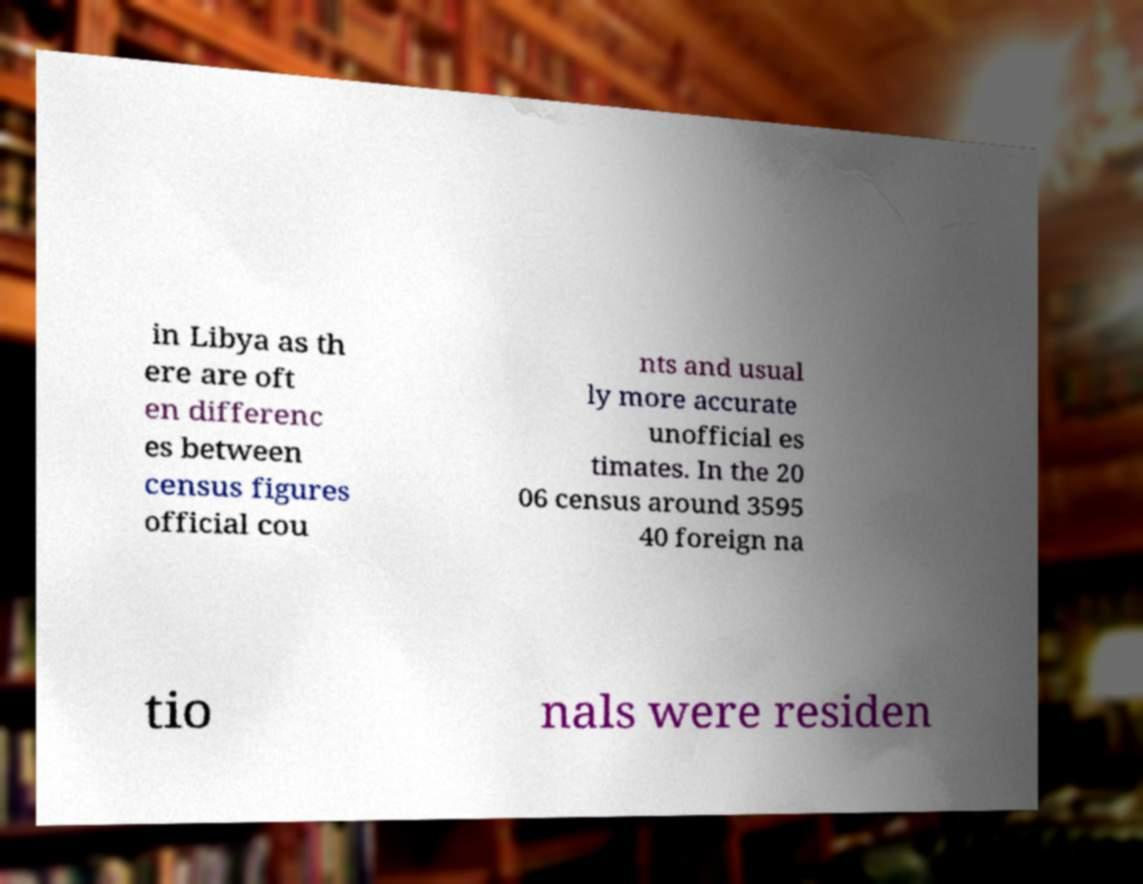Please identify and transcribe the text found in this image. in Libya as th ere are oft en differenc es between census figures official cou nts and usual ly more accurate unofficial es timates. In the 20 06 census around 3595 40 foreign na tio nals were residen 